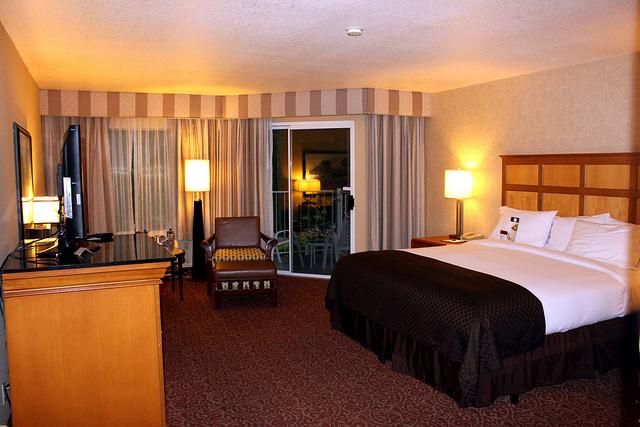Is there a TV in this room?
Quick response, please. Yes. Is the light on?
Answer briefly. Yes. What color are the pillows on the bed?
Answer briefly. White. 